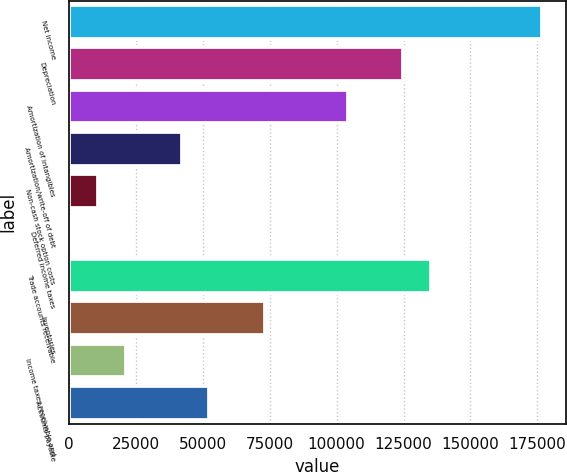Convert chart. <chart><loc_0><loc_0><loc_500><loc_500><bar_chart><fcel>Net income<fcel>Depreciation<fcel>Amortization of intangibles<fcel>Amortization/write-off of debt<fcel>Non-cash stock option costs<fcel>Deferred income taxes<fcel>Trade accounts receivable<fcel>Inventories<fcel>Income taxes receivable and<fcel>Accounts payable<nl><fcel>176691<fcel>124927<fcel>104221<fcel>42104.2<fcel>11045.8<fcel>693<fcel>135279<fcel>73162.6<fcel>21398.6<fcel>52457<nl></chart> 